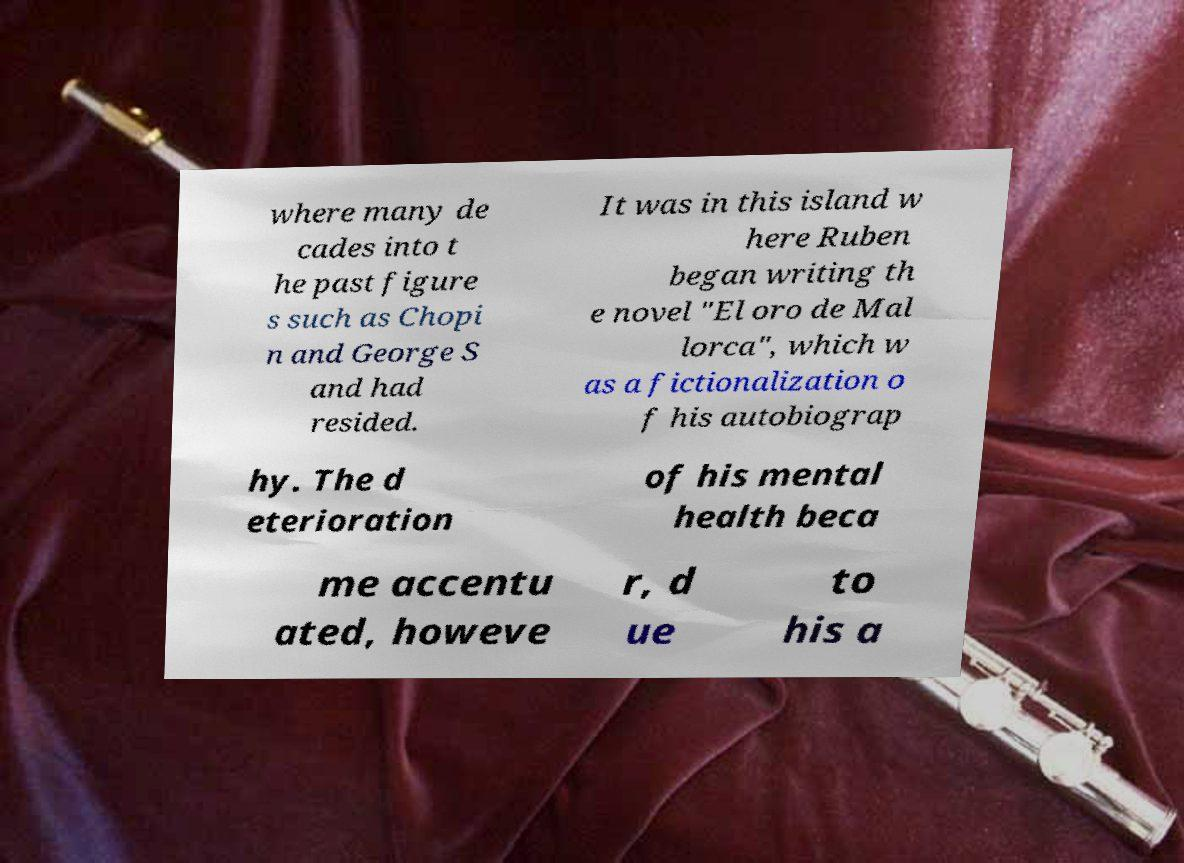Could you extract and type out the text from this image? where many de cades into t he past figure s such as Chopi n and George S and had resided. It was in this island w here Ruben began writing th e novel "El oro de Mal lorca", which w as a fictionalization o f his autobiograp hy. The d eterioration of his mental health beca me accentu ated, howeve r, d ue to his a 